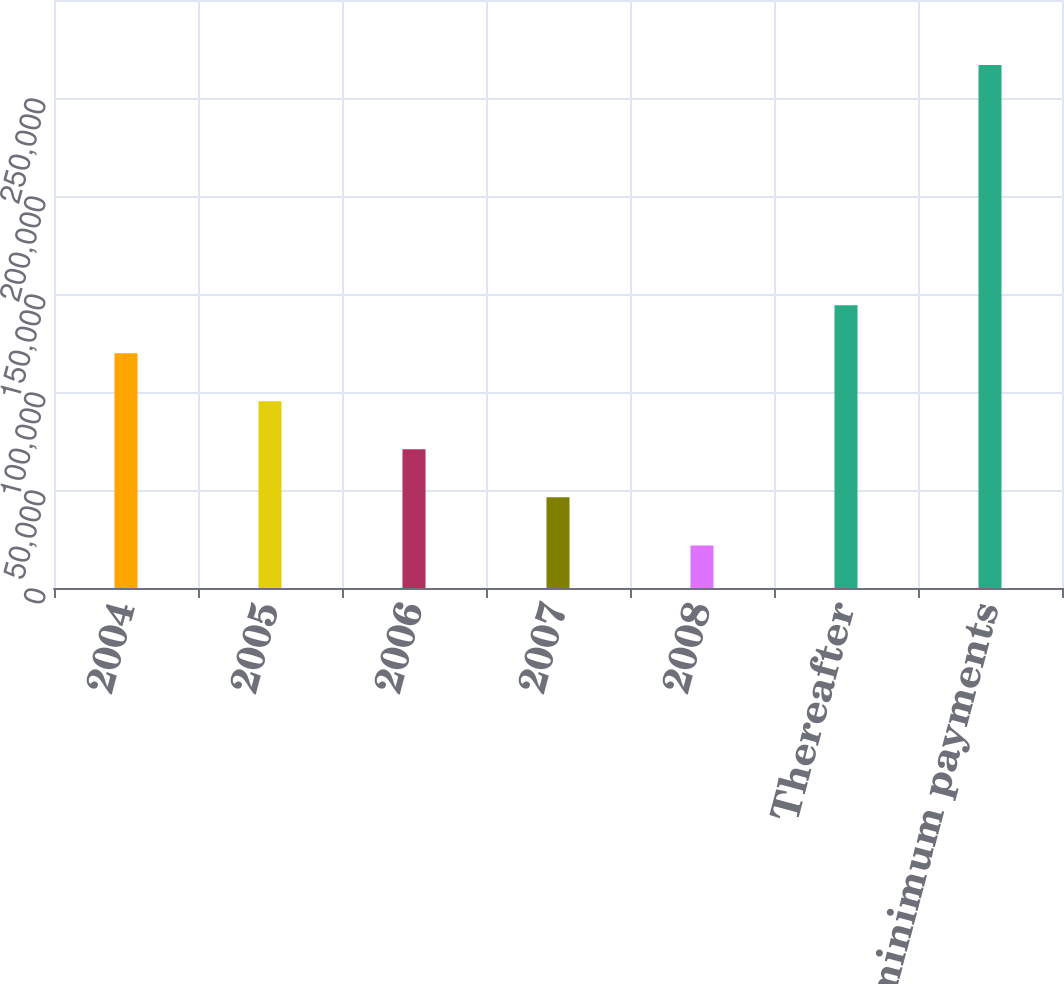<chart> <loc_0><loc_0><loc_500><loc_500><bar_chart><fcel>2004<fcel>2005<fcel>2006<fcel>2007<fcel>2008<fcel>Thereafter<fcel>Total minimum payments<nl><fcel>119770<fcel>95260.5<fcel>70751<fcel>46241.5<fcel>21732<fcel>144280<fcel>266827<nl></chart> 